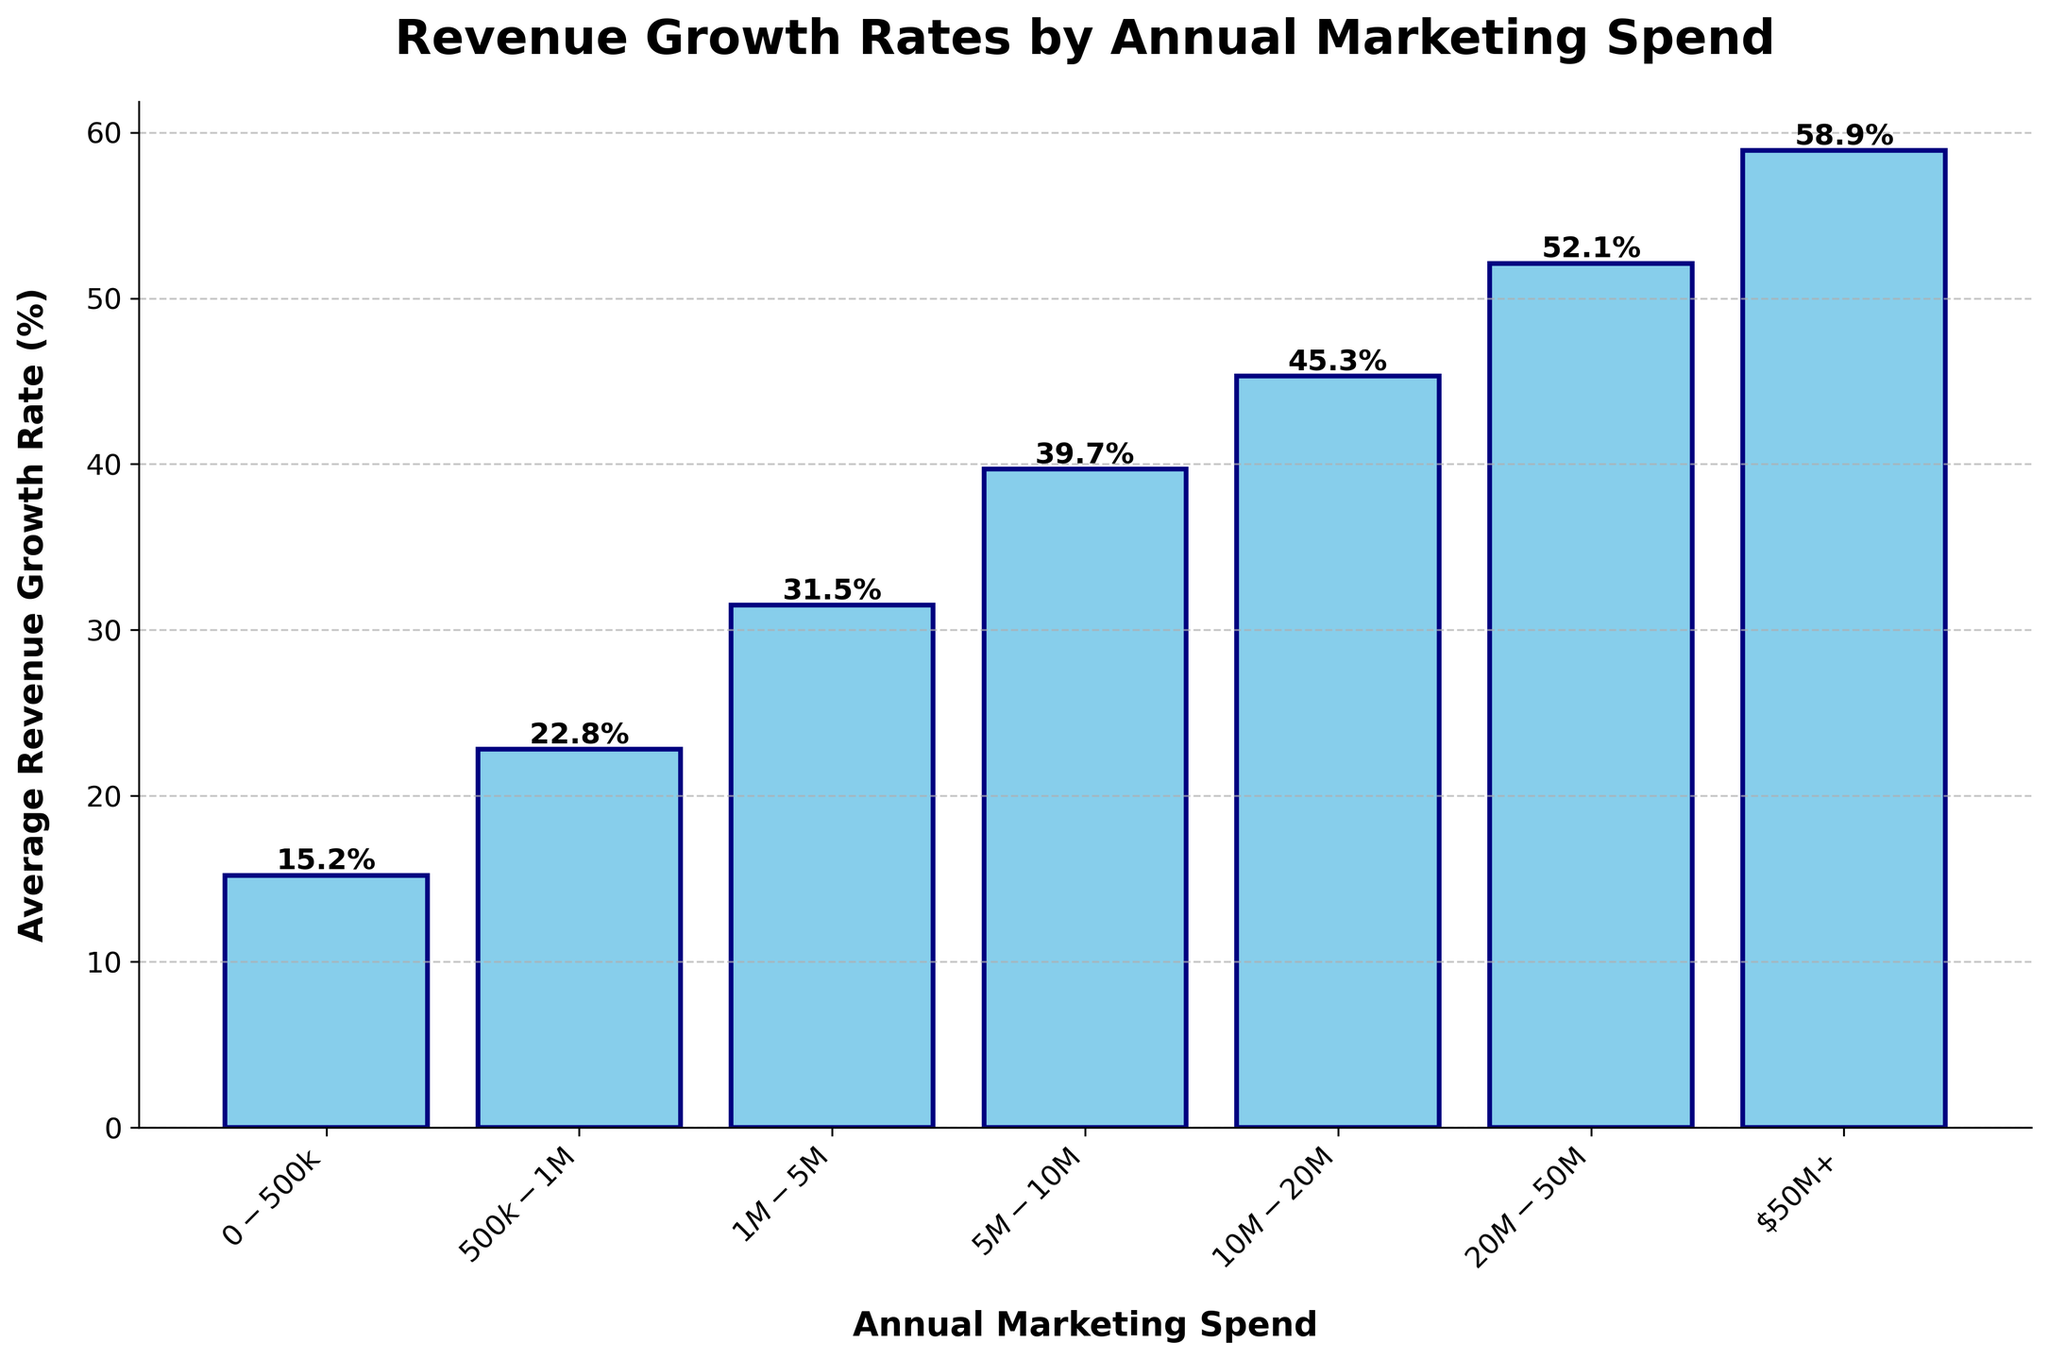Which marketing spend category has the highest average revenue growth rate? The bar corresponding to the highest average revenue growth rate is visually the tallest bar. By inspecting the chart, the marketing spend category "$50M+" has the tallest bar.
Answer: $50M+ What is the average revenue growth rate for companies spending between $1M and $5M annually on marketing? The bar for the "$1M-$5M" category depicts the average revenue growth rate as 31.5%. Simply refer to this bar to find the desired value.
Answer: 31.5% How much higher is the average revenue growth rate for companies with a marketing spend category of "$10M-$20M" compared to "$0-$500k"? From the chart, the average revenue growth rate for "$10M-$20M" is 45.3%, and for "$0-$500k" it is 15.2%. The difference is calculated as 45.3% - 15.2%.
Answer: 30.1% What is the increase in the average revenue growth rate from one marketing spend category to the next? Calculate the increase from "$0-$500k" to "$500k-$1M". The average revenue growth rate for "$0-$500k" is 15.2%, and for "$500k-$1M" it is 22.8%. Calculate the difference: 22.8% - 15.2%.
Answer: 7.6% Compare the average revenue growth rate for companies with annual marketing spends of "$20M-$50M" and "$50M+". Which is higher, and by how much? The average revenue growth rate for "$20M-$50M" is 52.1%, and for "$50M+" it is 58.9%. The "$50M+" category is higher. The difference is 58.9% - 52.1%.
Answer: 6.8% Identify the median value of the average revenue growth rates presented in the chart. Order the average revenue growth rates: 15.2%, 22.8%, 31.5%, 39.7%, 45.3%, 52.1%, 58.9%. With seven values, the median is the fourth value in the ordered list, which is 39.7%.
Answer: 39.7% What is the visual difference between the bar representing $0-$500k and the bar representing $50M+ in terms of height? The bar for "$0-$500k" is much shorter compared to the "$50M+" bar, indicating a lower average revenue growth rate. Specifically, the "$0-$500k" has 15.2% while the "$50M+" bar has 58.9%. The visual difference in height corresponds to the difference in these rates.
Answer: 43.7% 